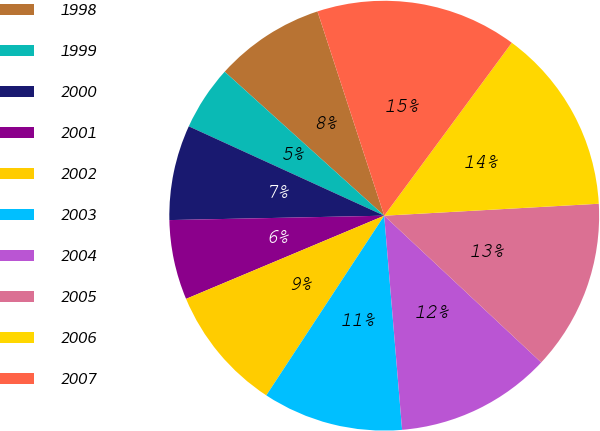Convert chart to OTSL. <chart><loc_0><loc_0><loc_500><loc_500><pie_chart><fcel>1998<fcel>1999<fcel>2000<fcel>2001<fcel>2002<fcel>2003<fcel>2004<fcel>2005<fcel>2006<fcel>2007<nl><fcel>8.29%<fcel>4.86%<fcel>7.15%<fcel>6.0%<fcel>9.43%<fcel>10.57%<fcel>11.71%<fcel>12.85%<fcel>14.0%<fcel>15.14%<nl></chart> 